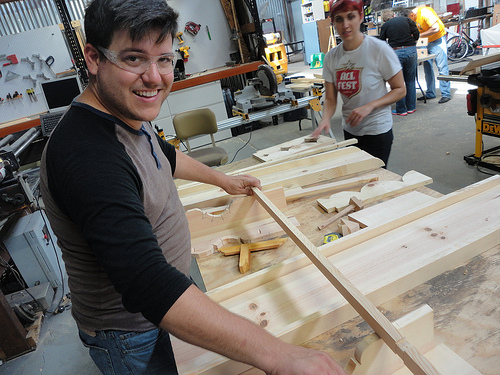<image>
Is the bike on the floor? Yes. Looking at the image, I can see the bike is positioned on top of the floor, with the floor providing support. Is there a man behind the woman? Yes. From this viewpoint, the man is positioned behind the woman, with the woman partially or fully occluding the man. 